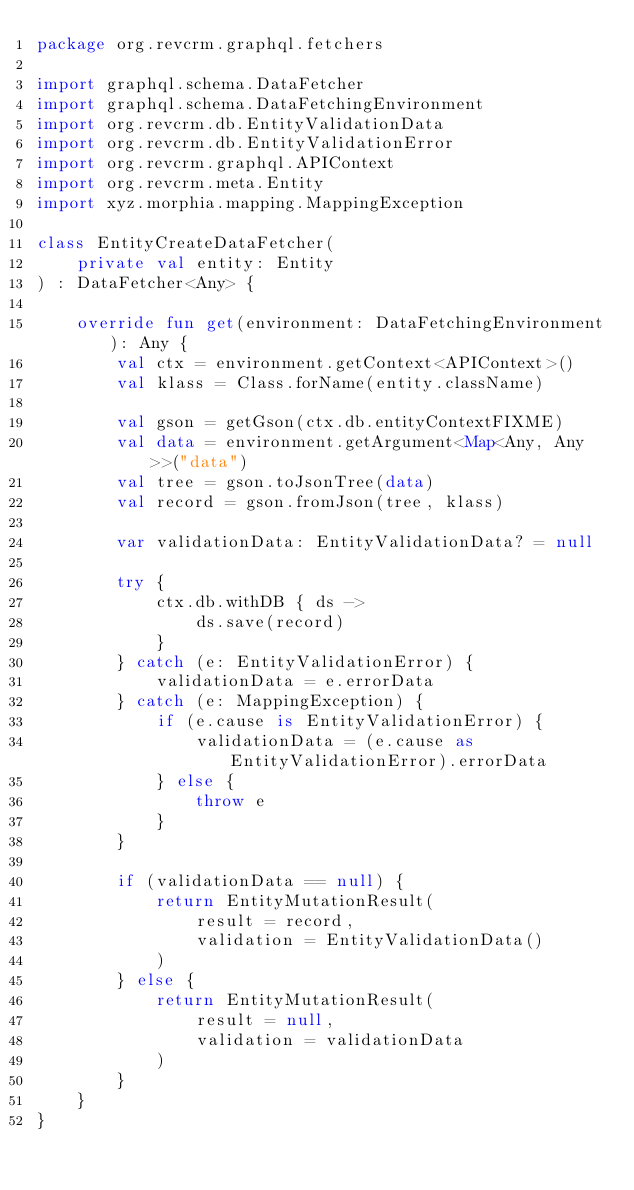Convert code to text. <code><loc_0><loc_0><loc_500><loc_500><_Kotlin_>package org.revcrm.graphql.fetchers

import graphql.schema.DataFetcher
import graphql.schema.DataFetchingEnvironment
import org.revcrm.db.EntityValidationData
import org.revcrm.db.EntityValidationError
import org.revcrm.graphql.APIContext
import org.revcrm.meta.Entity
import xyz.morphia.mapping.MappingException

class EntityCreateDataFetcher(
    private val entity: Entity
) : DataFetcher<Any> {

    override fun get(environment: DataFetchingEnvironment): Any {
        val ctx = environment.getContext<APIContext>()
        val klass = Class.forName(entity.className)

        val gson = getGson(ctx.db.entityContextFIXME)
        val data = environment.getArgument<Map<Any, Any>>("data")
        val tree = gson.toJsonTree(data)
        val record = gson.fromJson(tree, klass)

        var validationData: EntityValidationData? = null

        try {
            ctx.db.withDB { ds ->
                ds.save(record)
            }
        } catch (e: EntityValidationError) {
            validationData = e.errorData
        } catch (e: MappingException) {
            if (e.cause is EntityValidationError) {
                validationData = (e.cause as EntityValidationError).errorData
            } else {
                throw e
            }
        }

        if (validationData == null) {
            return EntityMutationResult(
                result = record,
                validation = EntityValidationData()
            )
        } else {
            return EntityMutationResult(
                result = null,
                validation = validationData
            )
        }
    }
}</code> 